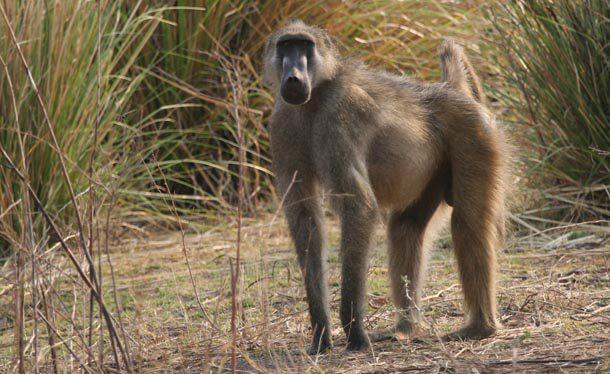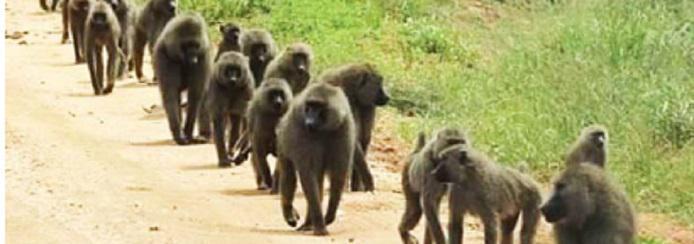The first image is the image on the left, the second image is the image on the right. Assess this claim about the two images: "At least two animals are huddled together.". Correct or not? Answer yes or no. No. The first image is the image on the left, the second image is the image on the right. Examine the images to the left and right. Is the description "Some chimpanzees are walking." accurate? Answer yes or no. Yes. 